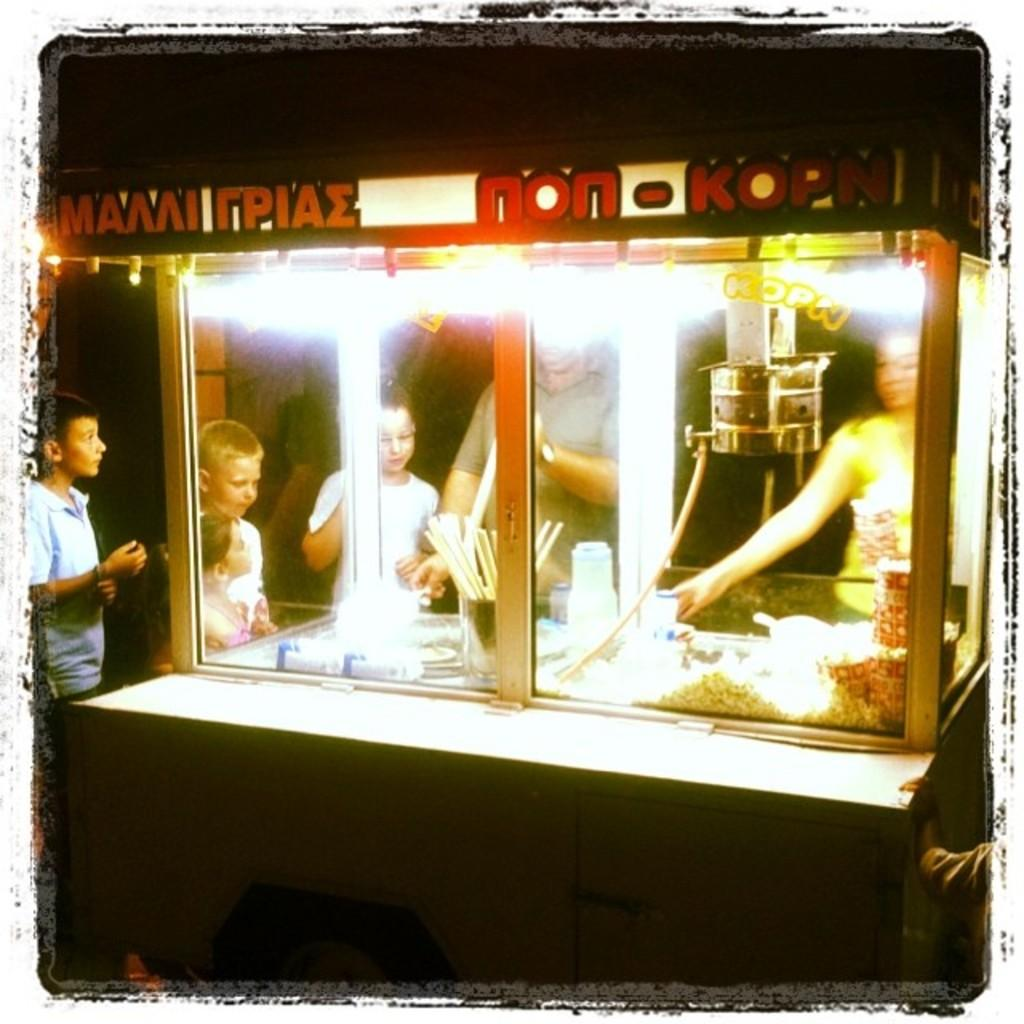What type of establishment is shown in the image? There is a stall in the image. Are there any people present at the stall? Yes, there are people present in the image. What items can be seen on display at the stall? Bottles, sticks, and glasses are visible in the image. What type of food is visible in the image? There is food visible in the image. How does the stall encourage people to cry in the image? The stall does not encourage people to cry in the image; it is a place where food and other items are displayed and sold. 